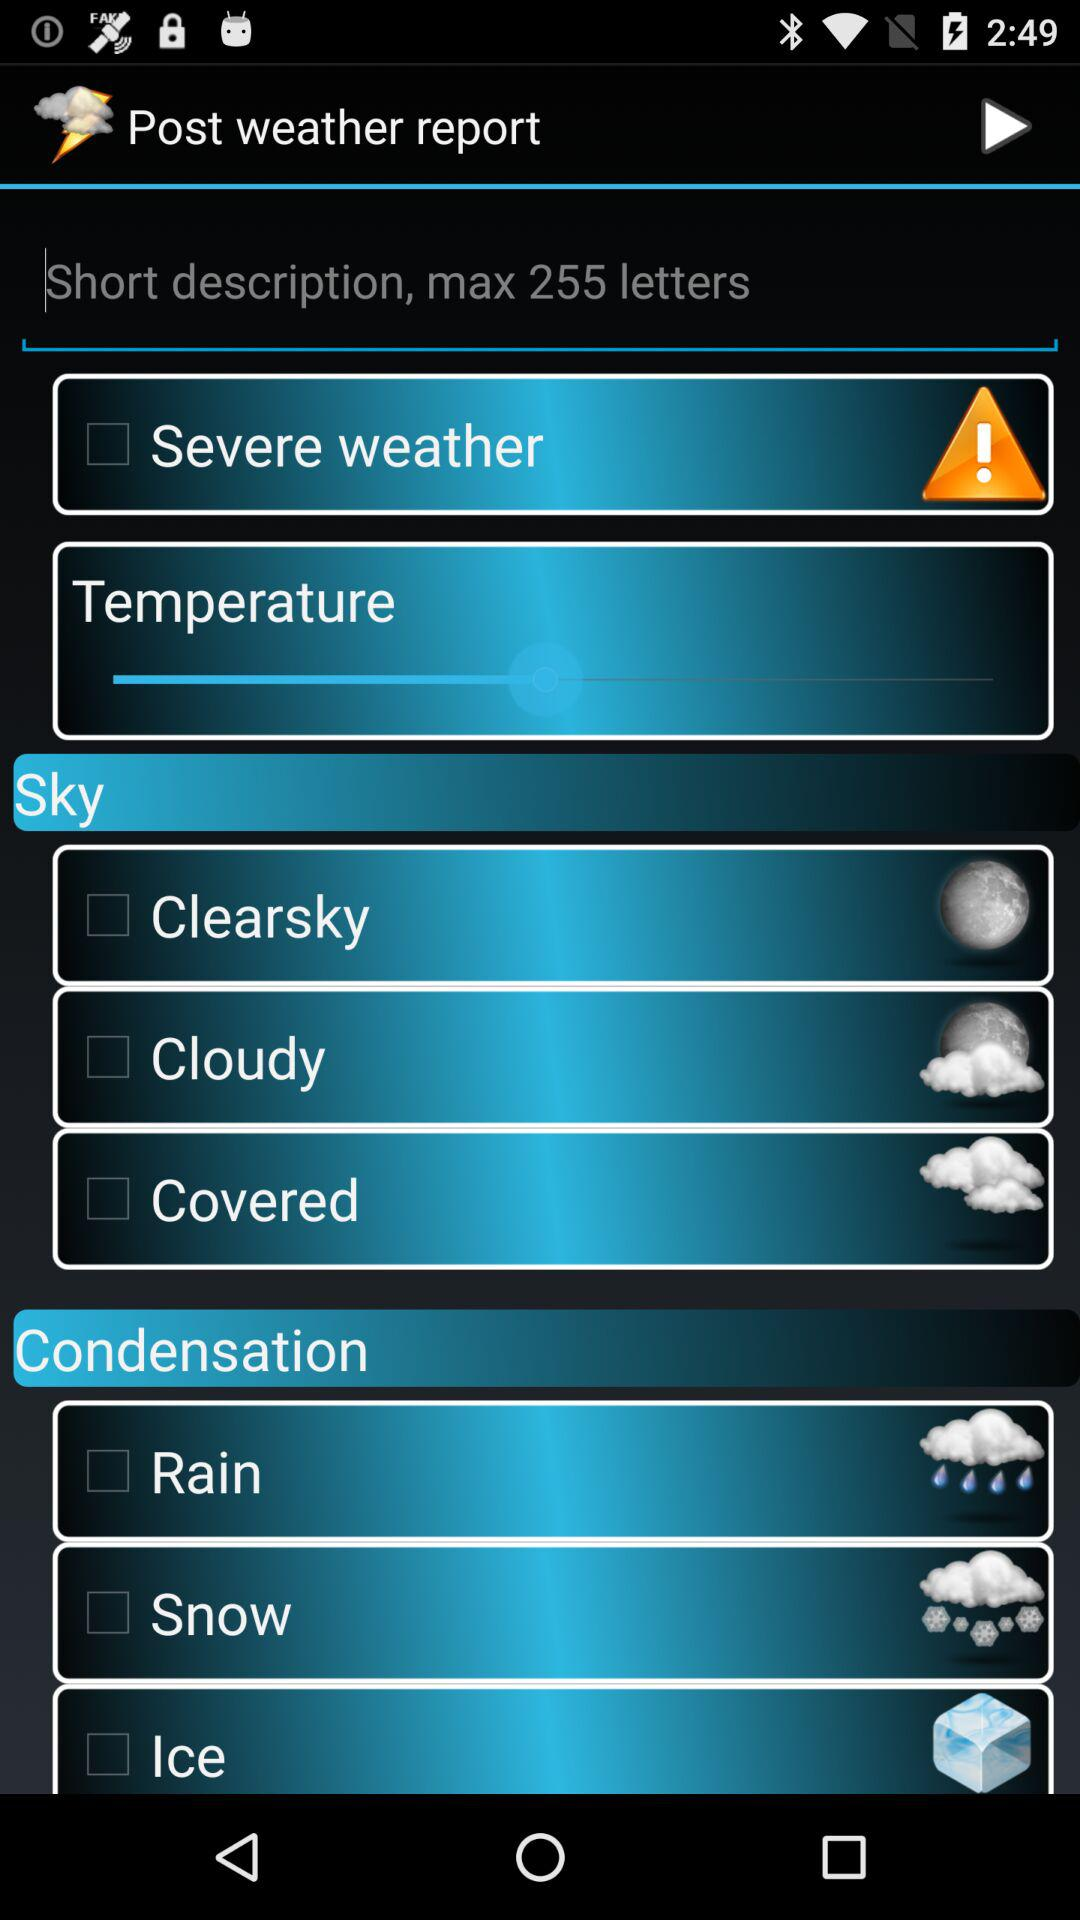What is the maximum number of letters? The maximum number of letters is 255. 